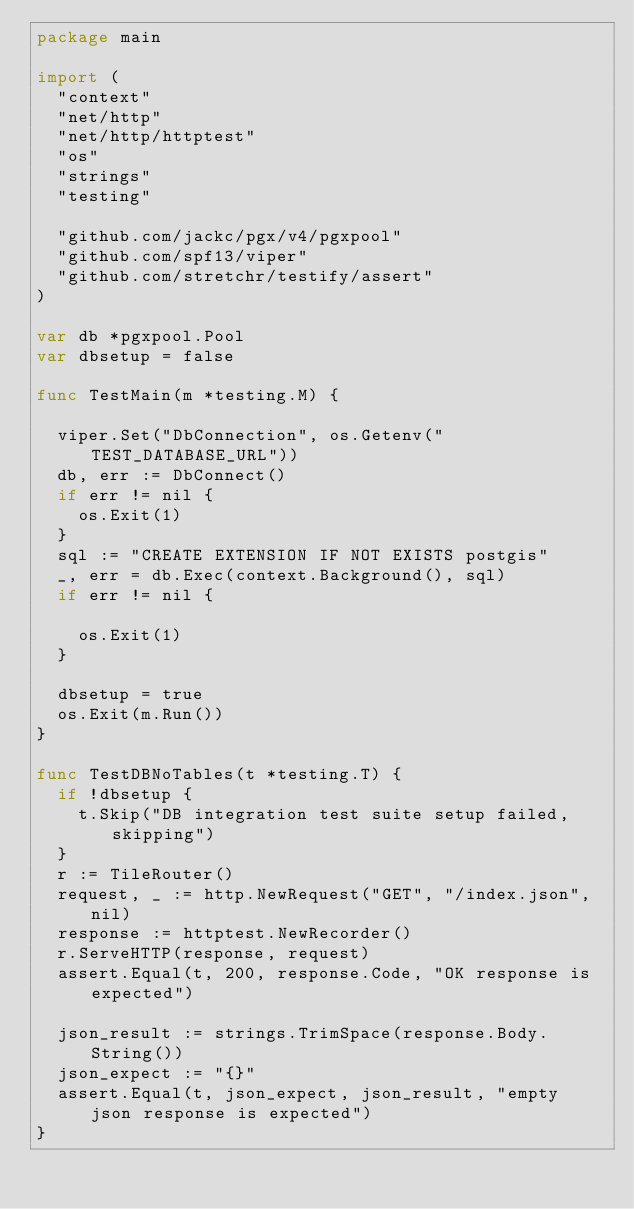Convert code to text. <code><loc_0><loc_0><loc_500><loc_500><_Go_>package main

import (
	"context"
	"net/http"
	"net/http/httptest"
	"os"
	"strings"
	"testing"

	"github.com/jackc/pgx/v4/pgxpool"
	"github.com/spf13/viper"
	"github.com/stretchr/testify/assert"
)

var db *pgxpool.Pool
var dbsetup = false

func TestMain(m *testing.M) {

	viper.Set("DbConnection", os.Getenv("TEST_DATABASE_URL"))
	db, err := DbConnect()
	if err != nil {
		os.Exit(1)
	}
	sql := "CREATE EXTENSION IF NOT EXISTS postgis"
	_, err = db.Exec(context.Background(), sql)
	if err != nil {

		os.Exit(1)
	}

	dbsetup = true
	os.Exit(m.Run())
}

func TestDBNoTables(t *testing.T) {
	if !dbsetup {
		t.Skip("DB integration test suite setup failed, skipping")
	}
	r := TileRouter()
	request, _ := http.NewRequest("GET", "/index.json", nil)
	response := httptest.NewRecorder()
	r.ServeHTTP(response, request)
	assert.Equal(t, 200, response.Code, "OK response is expected")

	json_result := strings.TrimSpace(response.Body.String())
	json_expect := "{}"
	assert.Equal(t, json_expect, json_result, "empty json response is expected")
}
</code> 